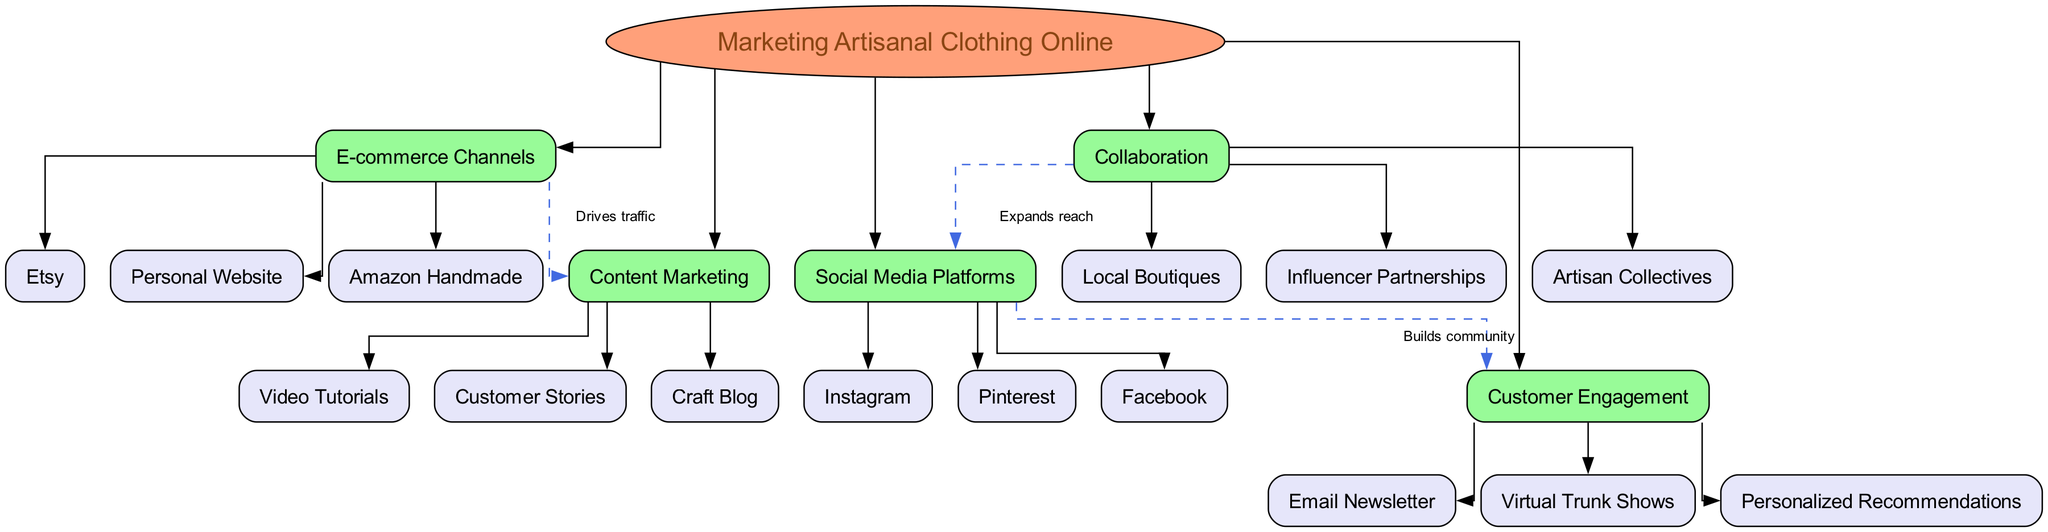What is the central concept of the diagram? The central concept node is explicitly labeled as "Marketing Artisanal Clothing Online." Since this is the primary idea being conveyed in the diagram, it is the first place to look for the answer.
Answer: Marketing Artisanal Clothing Online How many main branches are there? There are five main branches represented in the diagram that stem from the central concept. By counting these branches, it becomes clear that the total is five.
Answer: 5 Which sub-branch is part of the "E-commerce Channels"? One of the sub-branches under "E-commerce Channels" is "Etsy," which can be directly identified as it is connected to that particular main branch.
Answer: Etsy What do "Social Media Platforms" and "Customer Engagement" have in common? Both branches are connected by an edge labeled "Builds community," indicating their relationship. The diagram marks this connection specifically, demonstrating how social media can positively impact customer engagement.
Answer: Builds community What is the relationship between "Collaboration" and "Social Media Platforms"? The relationship is defined by an edge connecting these two branches, labeled as "Expands reach." This clearly shows how collaboration efforts can enhance the visibility on social media platforms.
Answer: Expands reach Which content type drives traffic to "E-commerce Channels"? "Content Marketing" specifically drives traffic towards "E-commerce Channels." The relevant edge labeled "Drives traffic" defines this relationship clearly.
Answer: Drives traffic What type of content is used for customer engagement? "Email Newsletter" is one of the sub-branches listed under "Customer Engagement," providing a direct answer to the type of content utilized for engaging customers.
Answer: Email Newsletter What type of marketing strategy involves "Influencer Partnerships"? "Collaboration" is the main branch that encompasses "Influencer Partnerships," linking these two areas of focus in marketing strategies effectively.
Answer: Collaboration How does "Craft Blog" relate to "Content Marketing"? "Craft Blog" is a sub-branch under "Content Marketing." Therefore, it is directly included and shows an example of how storytelling can be part of the overall content marketing strategy.
Answer: Content Marketing 